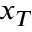<formula> <loc_0><loc_0><loc_500><loc_500>x _ { T }</formula> 